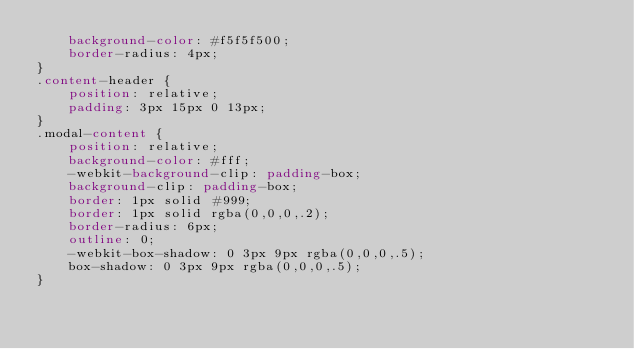<code> <loc_0><loc_0><loc_500><loc_500><_CSS_>    background-color: #f5f5f500;
    border-radius: 4px;
}
.content-header {
    position: relative;
    padding: 3px 15px 0 13px;
}
.modal-content {
    position: relative;
    background-color: #fff;
    -webkit-background-clip: padding-box;
    background-clip: padding-box;
    border: 1px solid #999;
    border: 1px solid rgba(0,0,0,.2);
    border-radius: 6px;
    outline: 0;
    -webkit-box-shadow: 0 3px 9px rgba(0,0,0,.5);
    box-shadow: 0 3px 9px rgba(0,0,0,.5);
}</code> 